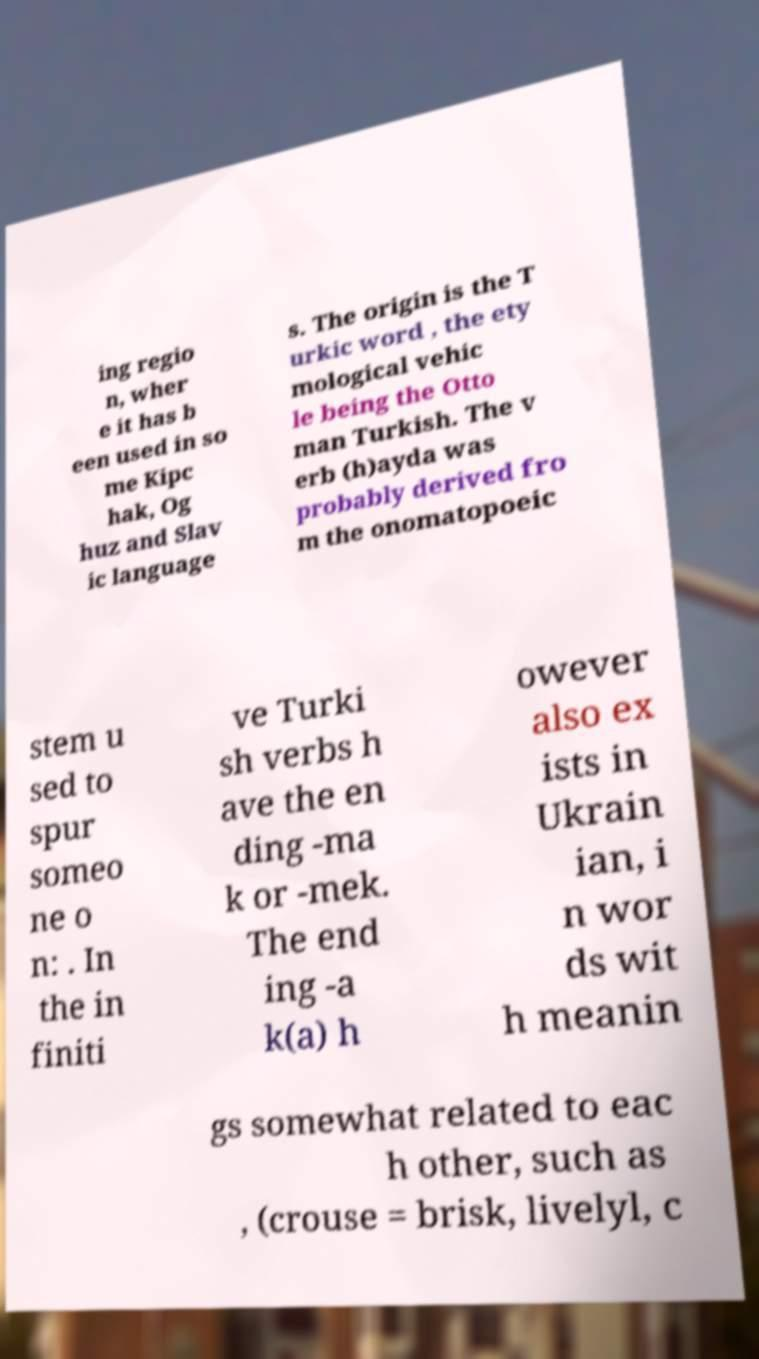Please identify and transcribe the text found in this image. ing regio n, wher e it has b een used in so me Kipc hak, Og huz and Slav ic language s. The origin is the T urkic word , the ety mological vehic le being the Otto man Turkish. The v erb (h)ayda was probably derived fro m the onomatopoeic stem u sed to spur someo ne o n: . In the in finiti ve Turki sh verbs h ave the en ding -ma k or -mek. The end ing -a k(a) h owever also ex ists in Ukrain ian, i n wor ds wit h meanin gs somewhat related to eac h other, such as , (crouse = brisk, livelyl, c 